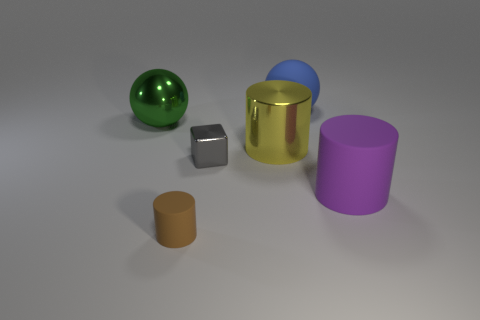Add 1 cylinders. How many objects exist? 7 Subtract all blocks. How many objects are left? 5 Subtract all big gray metallic balls. Subtract all blue matte things. How many objects are left? 5 Add 1 large things. How many large things are left? 5 Add 1 small objects. How many small objects exist? 3 Subtract 1 purple cylinders. How many objects are left? 5 